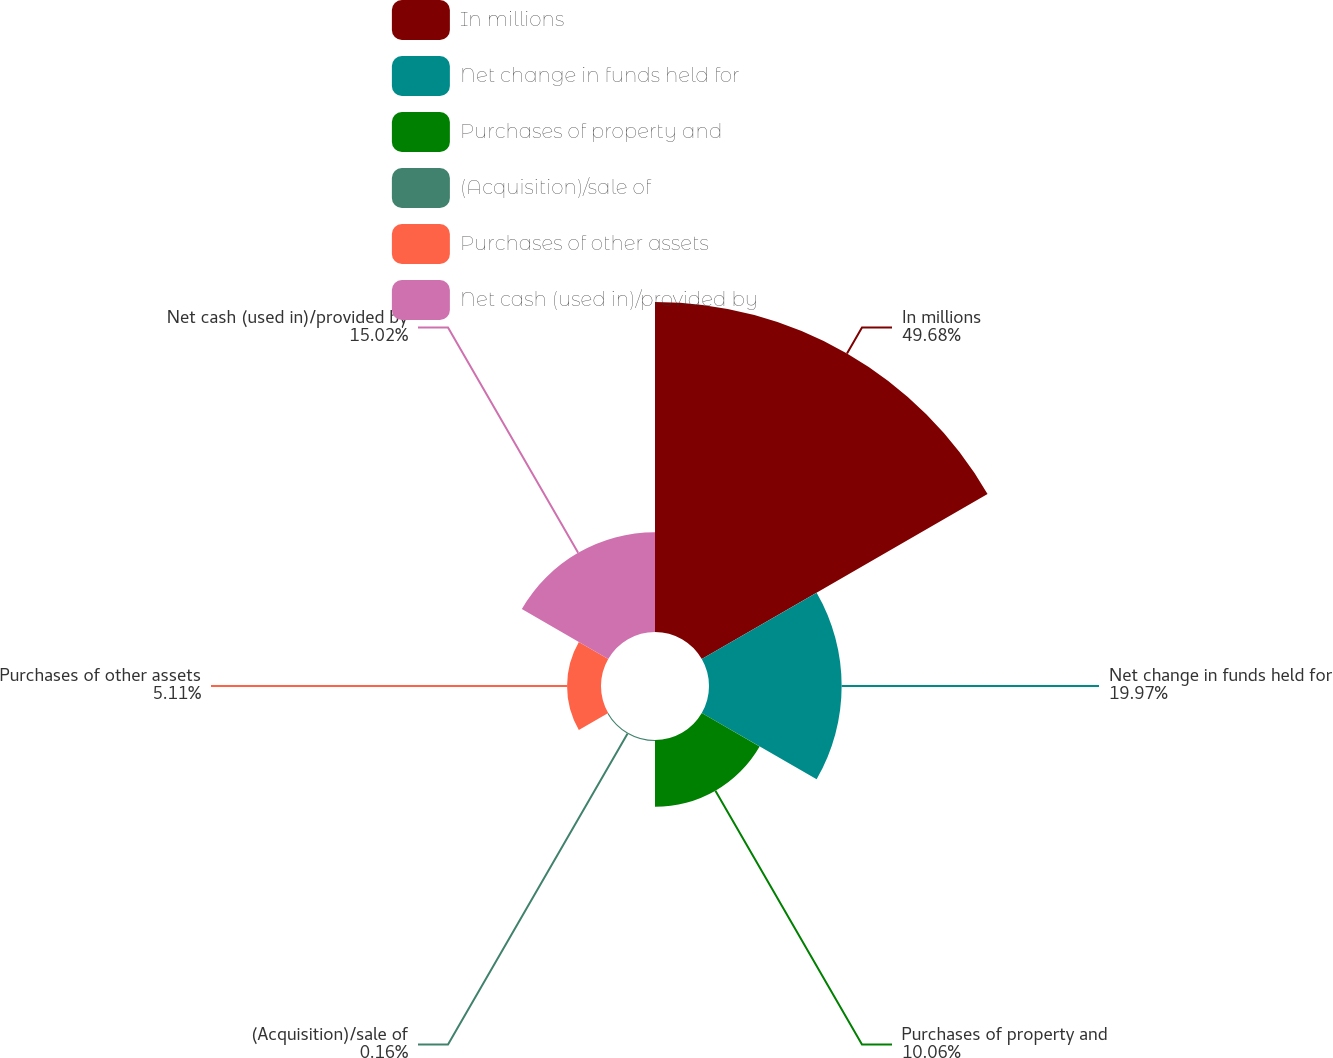Convert chart to OTSL. <chart><loc_0><loc_0><loc_500><loc_500><pie_chart><fcel>In millions<fcel>Net change in funds held for<fcel>Purchases of property and<fcel>(Acquisition)/sale of<fcel>Purchases of other assets<fcel>Net cash (used in)/provided by<nl><fcel>49.68%<fcel>19.97%<fcel>10.06%<fcel>0.16%<fcel>5.11%<fcel>15.02%<nl></chart> 